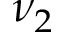<formula> <loc_0><loc_0><loc_500><loc_500>\nu _ { 2 }</formula> 